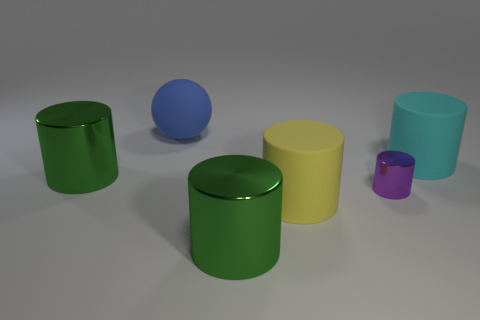What size is the purple object that is the same shape as the cyan object?
Offer a terse response. Small. Is there any other thing that is the same size as the purple metallic cylinder?
Keep it short and to the point. No. Are there more big cylinders to the right of the blue rubber ball than cyan rubber cylinders on the left side of the big yellow matte object?
Offer a terse response. Yes. Do the cyan rubber object and the purple metallic thing have the same size?
Ensure brevity in your answer.  No. The tiny metal thing that is the same shape as the large yellow thing is what color?
Ensure brevity in your answer.  Purple. Is the number of metal objects to the right of the ball greater than the number of blue objects?
Give a very brief answer. Yes. What color is the rubber thing on the right side of the purple metallic thing in front of the cyan rubber cylinder?
Make the answer very short. Cyan. What number of things are either rubber things that are left of the cyan rubber cylinder or cylinders that are left of the small metallic cylinder?
Ensure brevity in your answer.  4. The small metal cylinder is what color?
Keep it short and to the point. Purple. What number of other things are made of the same material as the large yellow thing?
Ensure brevity in your answer.  2. 